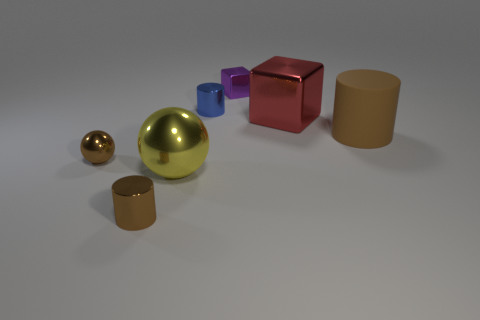Is the color of the cylinder on the right side of the purple thing the same as the cylinder that is in front of the big matte thing?
Make the answer very short. Yes. What number of cylinders have the same size as the yellow shiny sphere?
Ensure brevity in your answer.  1. Is the number of red cubes that are in front of the tiny brown shiny cylinder less than the number of yellow objects in front of the matte object?
Offer a terse response. Yes. What number of rubber things are brown blocks or large brown things?
Make the answer very short. 1. There is a large red object; what shape is it?
Your answer should be compact. Cube. What material is the red object that is the same size as the yellow thing?
Your answer should be compact. Metal. What number of small things are purple matte objects or yellow spheres?
Make the answer very short. 0. Is there a tiny purple metallic thing?
Give a very brief answer. Yes. There is a yellow ball that is the same material as the tiny brown sphere; what size is it?
Give a very brief answer. Large. Does the purple cube have the same material as the brown sphere?
Provide a succinct answer. Yes. 